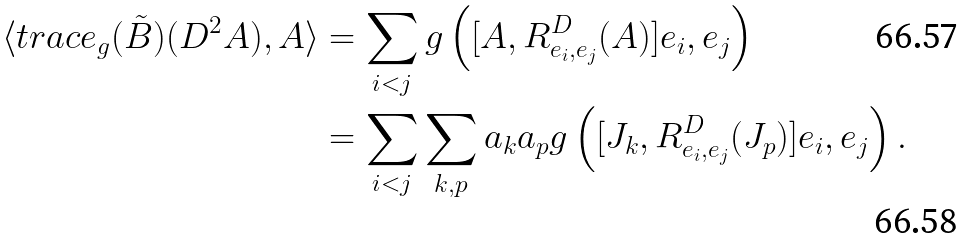Convert formula to latex. <formula><loc_0><loc_0><loc_500><loc_500>\langle t r a c e _ { g } ( \tilde { B } ) ( D ^ { 2 } A ) , A \rangle & = \sum _ { i < j } g \left ( [ A , R ^ { D } _ { e _ { i } , e _ { j } } ( A ) ] e _ { i } , e _ { j } \right ) \\ & = \sum _ { i < j } \sum _ { k , p } a _ { k } a _ { p } g \left ( [ J _ { k } , R ^ { D } _ { e _ { i } , e _ { j } } ( J _ { p } ) ] e _ { i } , e _ { j } \right ) .</formula> 